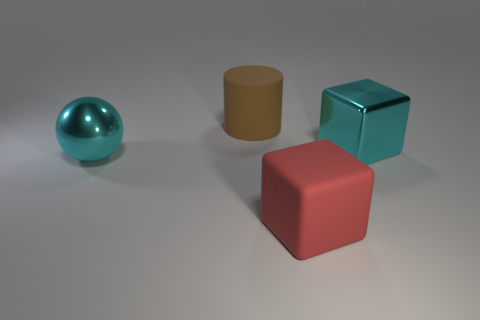Add 2 tiny red shiny cylinders. How many objects exist? 6 Subtract all balls. How many objects are left? 3 Subtract 0 blue blocks. How many objects are left? 4 Subtract all big cyan balls. Subtract all large rubber blocks. How many objects are left? 2 Add 3 red blocks. How many red blocks are left? 4 Add 4 large red things. How many large red things exist? 5 